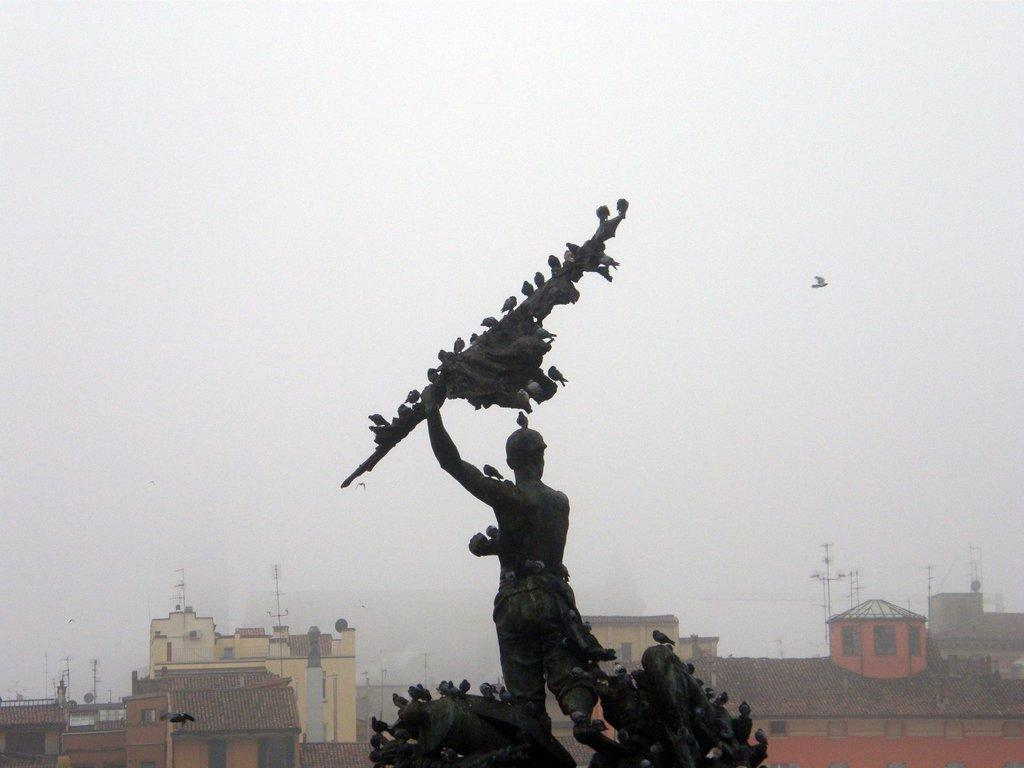What is the main subject in the middle of the image? There is a statue in the middle of the image. What is on the statue? There are birds on the statue. What can be seen in the background of the image? There are buildings in the background of the image. What is visible at the top of the image? The sky is visible at the top of the image. What type of key is used to unlock the statue in the image? There is no key present in the image, and the statue is not locked. 